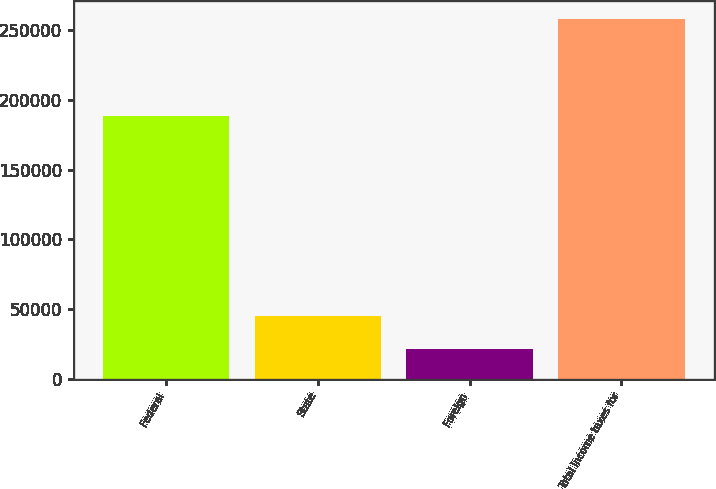Convert chart. <chart><loc_0><loc_0><loc_500><loc_500><bar_chart><fcel>Federal<fcel>State<fcel>Foreign<fcel>Total income taxes for<nl><fcel>188086<fcel>45072.4<fcel>21456<fcel>257620<nl></chart> 